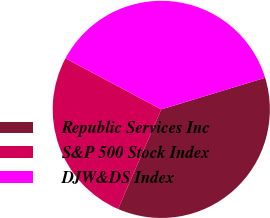Convert chart to OTSL. <chart><loc_0><loc_0><loc_500><loc_500><pie_chart><fcel>Republic Services Inc<fcel>S&P 500 Stock Index<fcel>DJW&DS Index<nl><fcel>36.22%<fcel>26.28%<fcel>37.5%<nl></chart> 